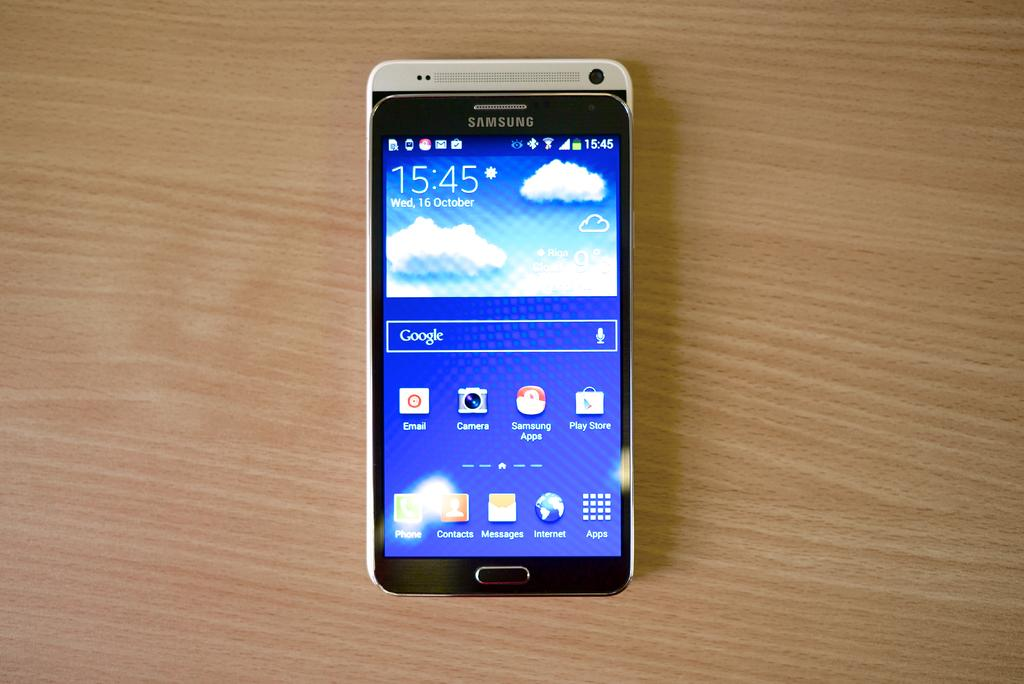<image>
Write a terse but informative summary of the picture. A cell phone with 15:45 and apps on the display. 